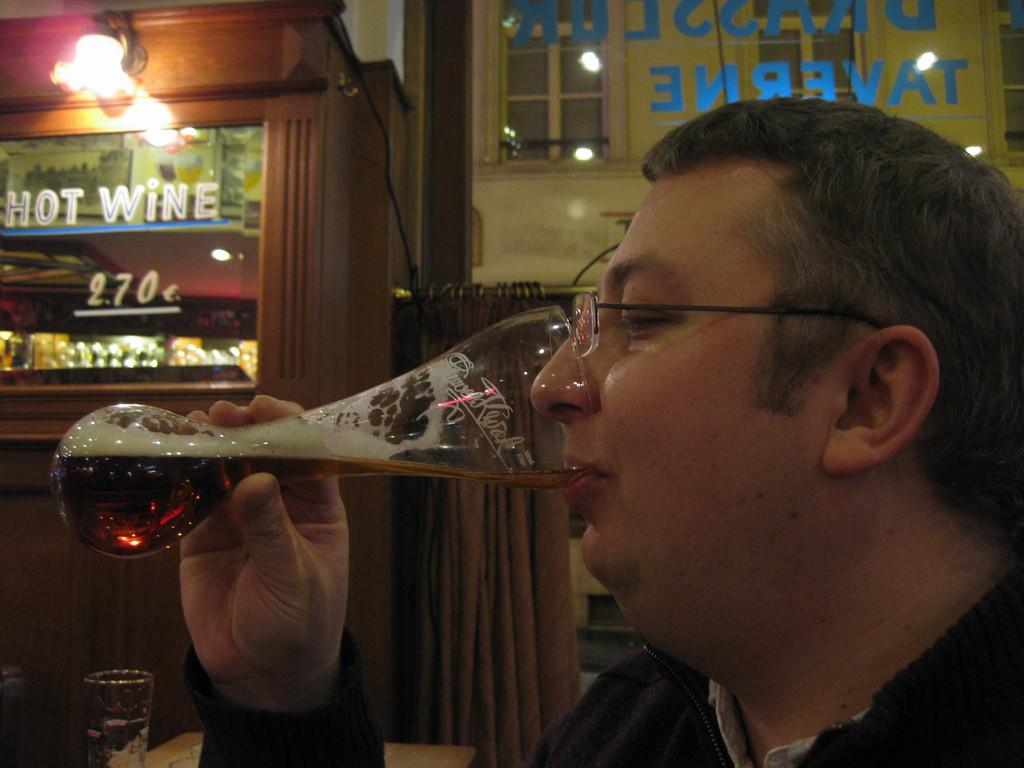Who is present in the image? There is a man in the image. What is the man holding in the image? The man is holding a glass. Where is the glass positioned in relation to the man? The glass is near the man's mouth. What can be seen in the background of the image? There is a shop and a curtain in the background of the image. Are there any other glasses visible in the image? Yes, there is another glass visible in the background of the image. What can be seen in the background of the image that indicates the presence of light? There is light visible in the background of the image. What type of riddle is the man trying to solve in the image? There is no indication in the image that the man is trying to solve a riddle. What kind of glue is being used to hold the glass together in the image? The glass in the image is not being held together with glue; it is a regular glass being held by the man. 